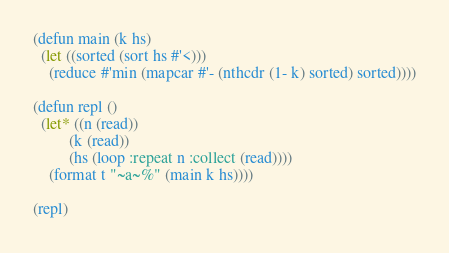<code> <loc_0><loc_0><loc_500><loc_500><_Lisp_>(defun main (k hs)
  (let ((sorted (sort hs #'<)))
    (reduce #'min (mapcar #'- (nthcdr (1- k) sorted) sorted))))

(defun repl ()
  (let* ((n (read))
         (k (read))
         (hs (loop :repeat n :collect (read))))
    (format t "~a~%" (main k hs))))

(repl)
</code> 